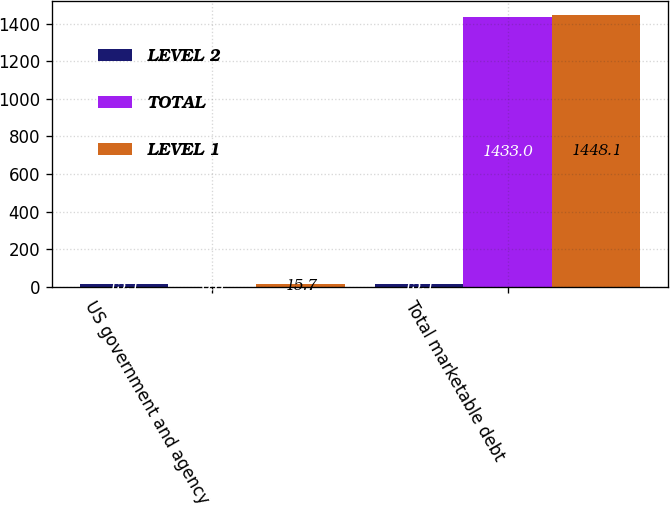Convert chart. <chart><loc_0><loc_0><loc_500><loc_500><stacked_bar_chart><ecel><fcel>US government and agency<fcel>Total marketable debt<nl><fcel>LEVEL 2<fcel>15.1<fcel>15.1<nl><fcel>TOTAL<fcel>0.6<fcel>1433<nl><fcel>LEVEL 1<fcel>15.7<fcel>1448.1<nl></chart> 